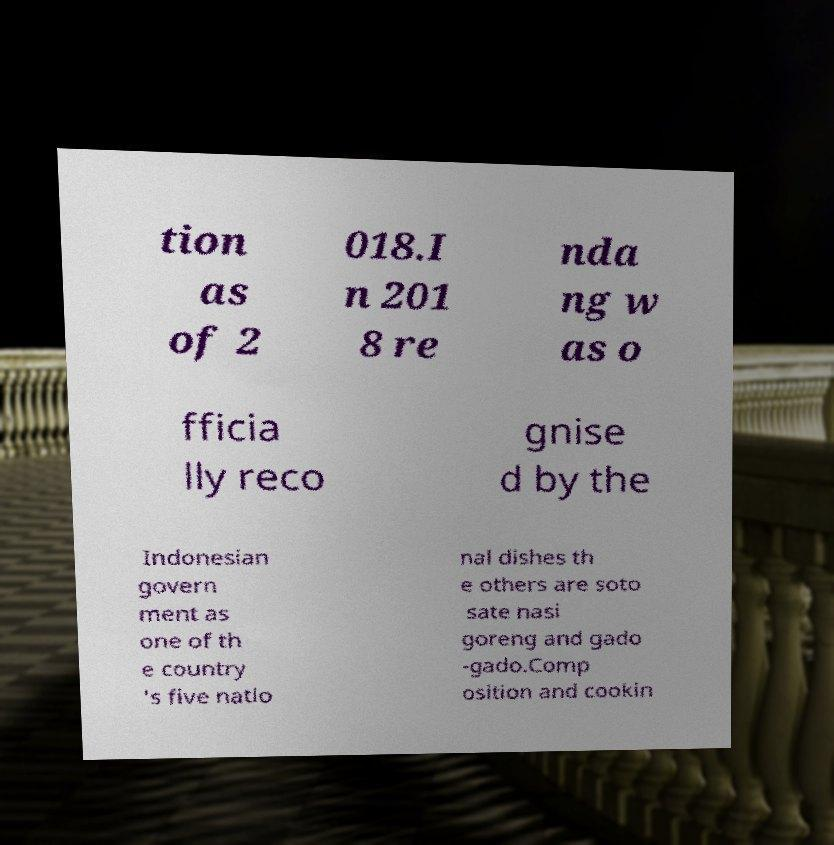I need the written content from this picture converted into text. Can you do that? tion as of 2 018.I n 201 8 re nda ng w as o fficia lly reco gnise d by the Indonesian govern ment as one of th e country 's five natio nal dishes th e others are soto sate nasi goreng and gado -gado.Comp osition and cookin 